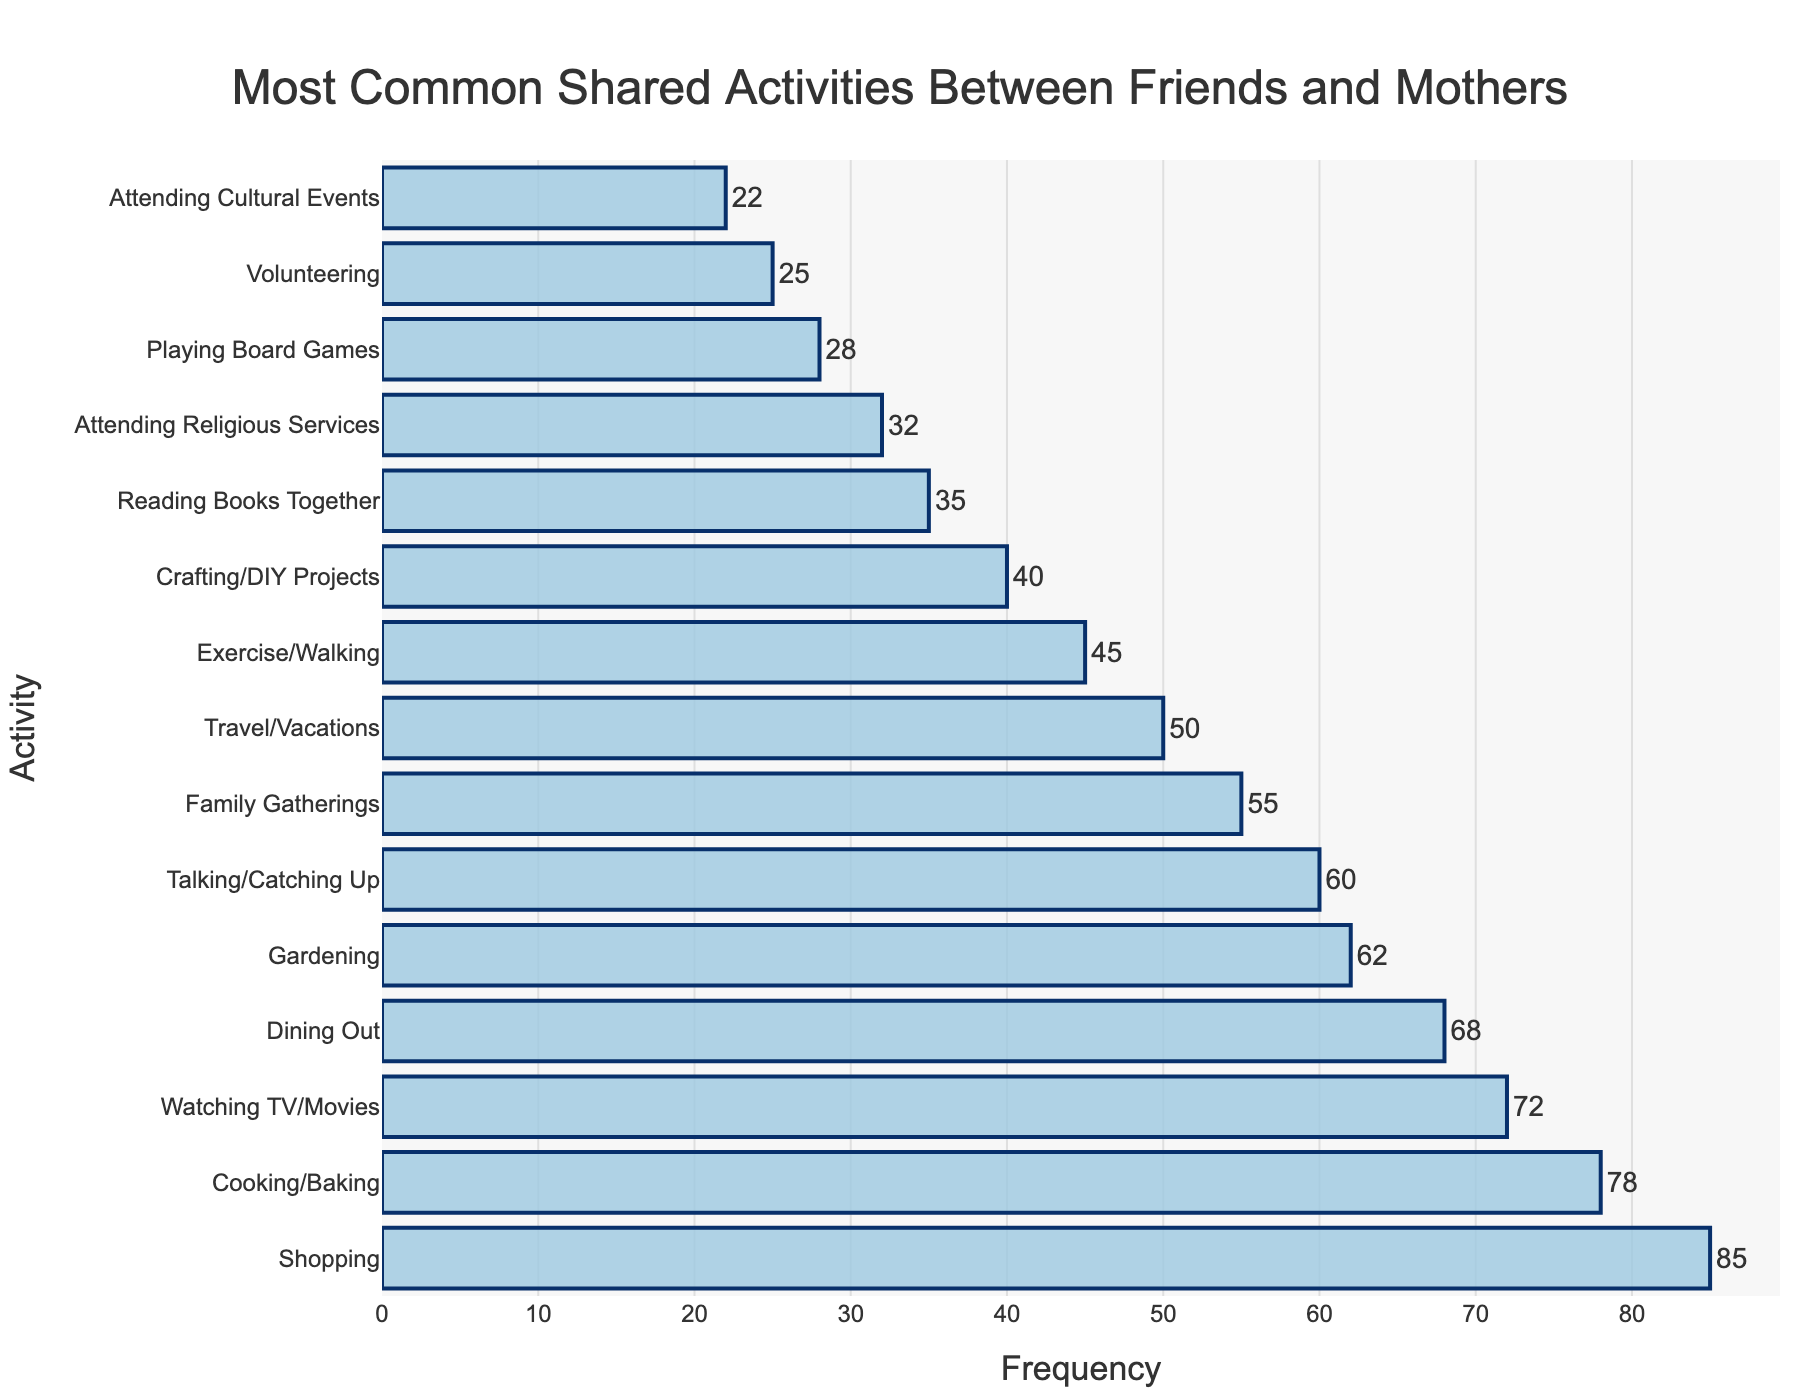Which activity is the most common shared activity between friends and their mothers? The highest bar on the chart represents the most common shared activity. The "Shopping" activity has the highest frequency.
Answer: Shopping Which activity has a frequency of 68? By looking at the bar that extends to the frequency value of 68 on the x-axis, we see that "Dining Out" is the activity with this frequency.
Answer: Dining Out How many activities have a frequency greater than 60? Count the number of bars that extend past the 60 mark on the x-axis. The activities are Shopping, Cooking/Baking, Watching TV/Movies, Dining Out, and Gardening, which are 5 activities in total.
Answer: 5 What is the difference in frequency between Gardening and Travel/Vacations? Locate the frequencies for both Gardening (62) and Travel/Vacations (50) and subtract the smaller from the larger: 62 - 50 = 12.
Answer: 12 Which activities have frequencies that differ by 2? Compare the lengths of the bars to find pairs whose frequencies differ by 2. "Gardening" (62) and "Talking/Catching Up" (60) is one such pair.
Answer: Gardening and Talking/Catching Up Is the frequency of Reading Books Together greater than Playing Board Games? Compare the lengths of the bars for Reading Books Together (35) and Playing Board Games (28). The bar for Reading Books Together is longer.
Answer: Yes What is the average frequency of the top three most common activities? Identify the top three activities: Shopping (85), Cooking/Baking (78), and Watching TV/Movies (72). Sum their frequencies and divide by 3: (85 + 78 + 72) / 3 = 78.33.
Answer: 78.33 Which activity has the lowest frequency on the chart? The shortest bar represents the activity with the lowest frequency. "Attending Cultural Events" has the shortest bar.
Answer: Attending Cultural Events What is the combined frequency of Crafting/DIY Projects and Volunteering? Look at the frequencies for both Crafting/DIY Projects (40) and Volunteering (25) and add them: 40 + 25 = 65.
Answer: 65 Is the frequency of Attending Religious Services equal to or greater than Playing Board Games? Compare the lengths of the bars for Attending Religious Services (32) and Playing Board Games (28). The bar for Attending Religious Services is longer.
Answer: Yes 